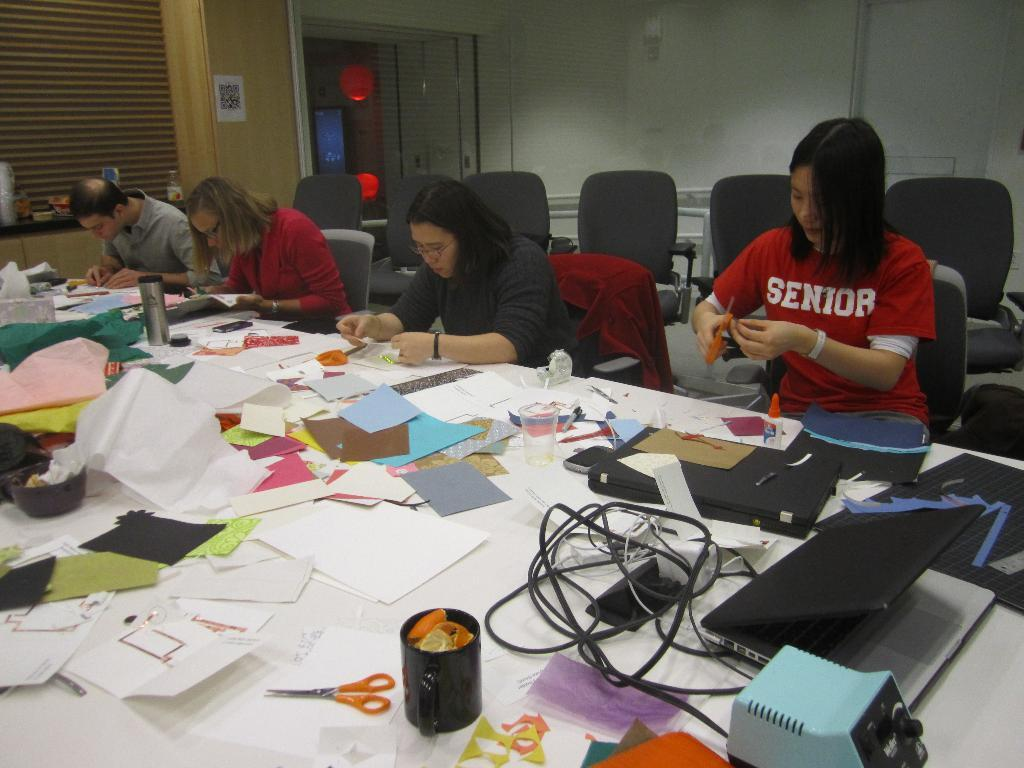<image>
Share a concise interpretation of the image provided. a lady wearing a tshirt showing 'Senior' working on some crafts 